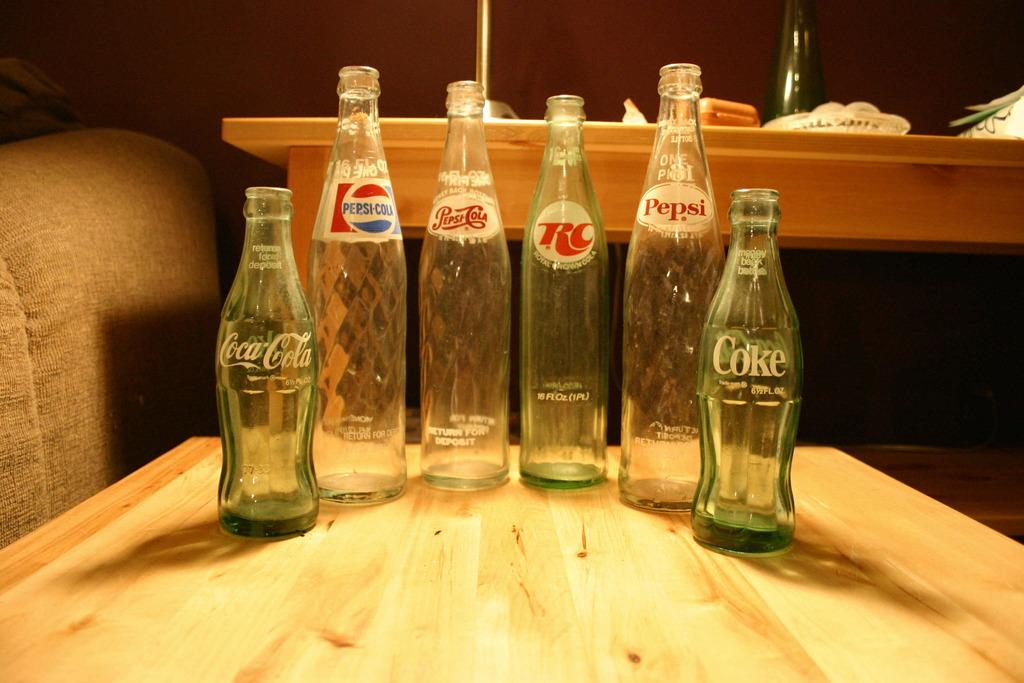What type of objects can be seen in the image? There are beverage bottles in the image. Where are the beverage bottles located? The beverage bottles are placed on a table. Can you describe the background of the image? There is a table with objects in the background of the image. What type of belief can be seen in the image? There is no belief present in the image; it features beverage bottles on a table. Can you describe the ocean in the image? There is no ocean present in the image; it only shows beverage bottles on a table and a background with objects on another table. 